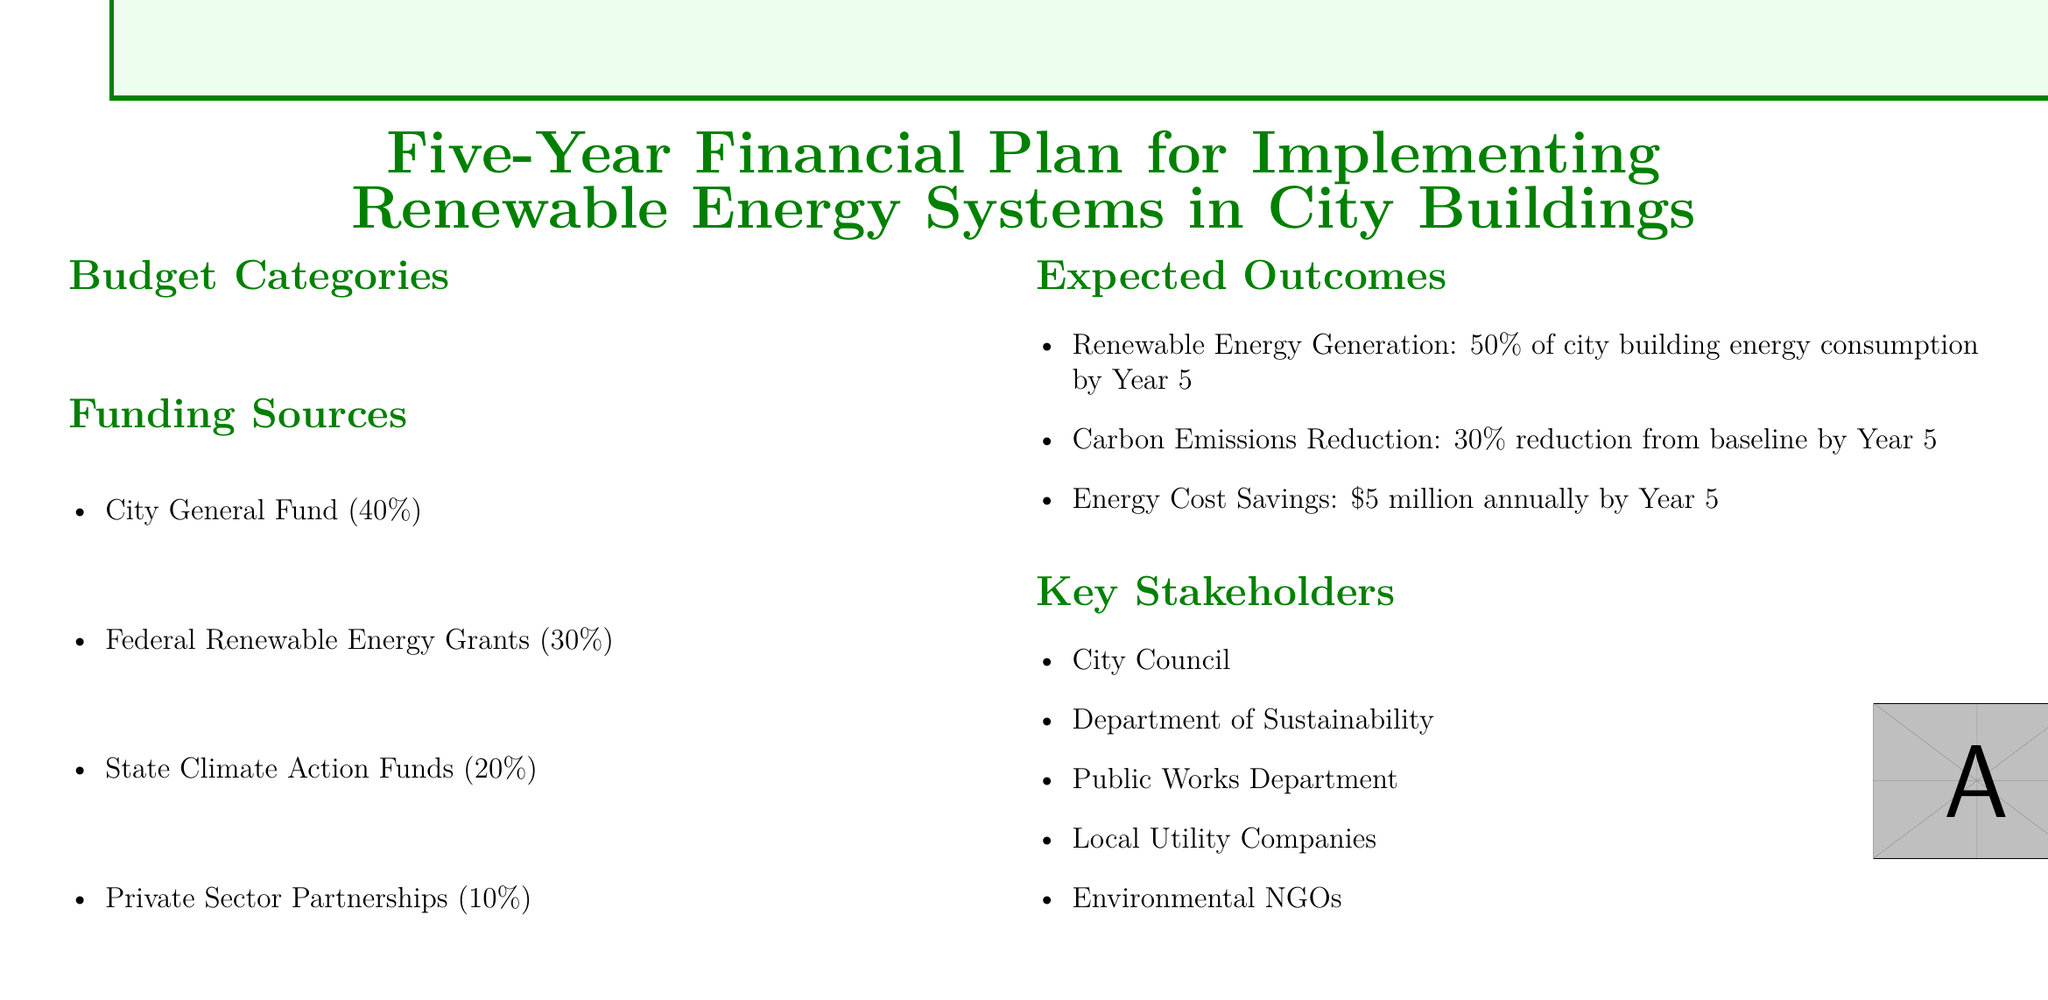What is the total budget for solar panel installation over five years? The total budget for solar panel installation is the sum of all yearly allocations: $2.5M + $3.0M + $3.5M + $3.0M + $2.5M = $14.5M.
Answer: $14.5M What percentage of funding comes from the City General Fund? The document states that 40% of the funding comes from the City General Fund.
Answer: 40% What is the expected reduction in carbon emissions by Year 5? The expected outcome for carbon emissions reduction is stated as a 30% reduction from baseline by Year 5.
Answer: 30% Which category has the highest budget in Year 3? In Year 3, solar panel installation has the highest budget at $3.5M.
Answer: Solar Panel Installation What is the annual energy cost savings expected by Year 5? The document specifies that energy cost savings are expected to be $5 million annually by Year 5.
Answer: $5 million Which year has the lowest budget for energy storage systems? The year with the lowest budget for energy storage systems is Year 5 with $1.0M allocated.
Answer: Year 5 What is the total allocation for smart grid infrastructure over five years? The total allocation for smart grid infrastructure is $0.8M + $1.2M + $1.5M + $1.2M + $0.8M = $5.5M.
Answer: $5.5M Who are the key stakeholders listed in the document? The key stakeholders include the City Council, Department of Sustainability, Public Works Department, Local Utility Companies, and Environmental NGOs.
Answer: City Council, Department of Sustainability, Public Works Department, Local Utility Companies, Environmental NGOs 